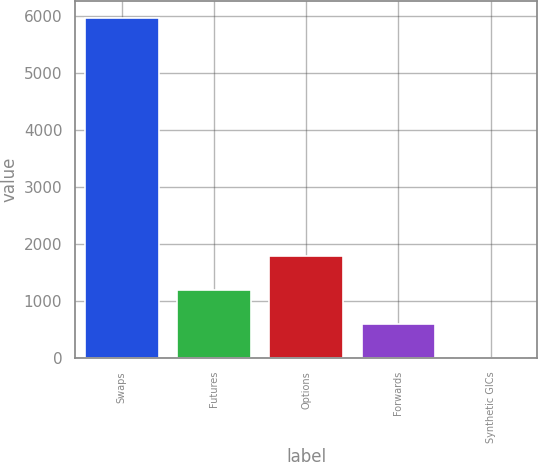<chart> <loc_0><loc_0><loc_500><loc_500><bar_chart><fcel>Swaps<fcel>Futures<fcel>Options<fcel>Forwards<fcel>Synthetic GICs<nl><fcel>5960<fcel>1195.45<fcel>1791.02<fcel>599.88<fcel>4.31<nl></chart> 